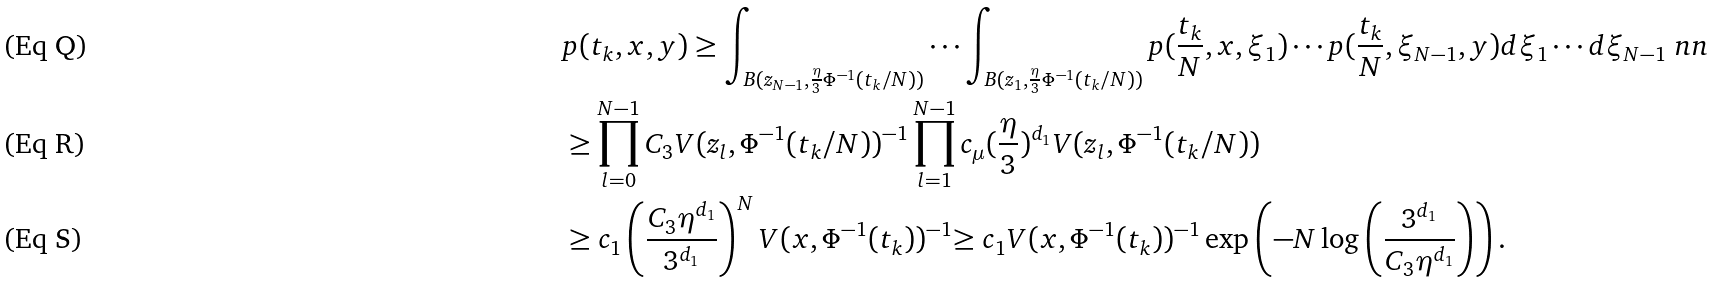Convert formula to latex. <formula><loc_0><loc_0><loc_500><loc_500>& p ( t _ { k } , x , y ) \geq \int _ { B ( z _ { N - 1 } , \frac { \eta } { 3 } \Phi ^ { - 1 } ( t _ { k } / N ) ) } \cdots \int _ { B ( z _ { 1 } , \frac { \eta } { 3 } \Phi ^ { - 1 } ( t _ { k } / N ) ) } p ( \frac { t _ { k } } { N } , x , \xi _ { 1 } ) \cdots p ( \frac { t _ { k } } { N } , \xi _ { N - 1 } , y ) d \xi _ { 1 } \cdots d \xi _ { N - 1 } \ n n \\ & \geq \prod _ { l = 0 } ^ { N - 1 } C _ { 3 } V ( z _ { l } , \Phi ^ { - 1 } ( t _ { k } / N ) ) ^ { - 1 } \prod _ { l = 1 } ^ { N - 1 } c _ { \mu } ( \frac { \eta } { 3 } ) ^ { d _ { 1 } } V ( z _ { l } , \Phi ^ { - 1 } ( t _ { k } / N ) ) \\ & \geq c _ { 1 } \left ( \frac { C _ { 3 } \eta ^ { d _ { 1 } } } { 3 ^ { d _ { 1 } } } \right ) ^ { N } V ( x , \Phi ^ { - 1 } ( t _ { k } ) ) ^ { - 1 } { \geq c _ { 1 } V ( x , \Phi ^ { - 1 } ( t _ { k } ) ) ^ { - 1 } \exp \left ( { - N \log \left ( \frac { 3 ^ { d _ { 1 } } } { C _ { 3 } \eta ^ { d _ { 1 } } } \right ) } \right ) . }</formula> 